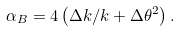Convert formula to latex. <formula><loc_0><loc_0><loc_500><loc_500>\alpha _ { B } = 4 \left ( { \Delta k } / { k } + \Delta \theta ^ { 2 } \right ) .</formula> 